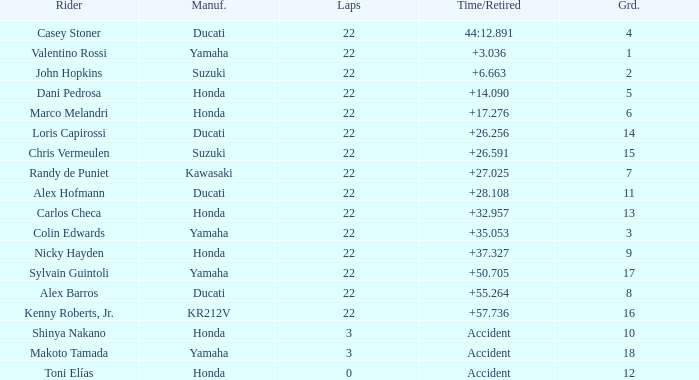What is the average grid for competitors who had more than 22 laps and time/retired of +17.276? None. 